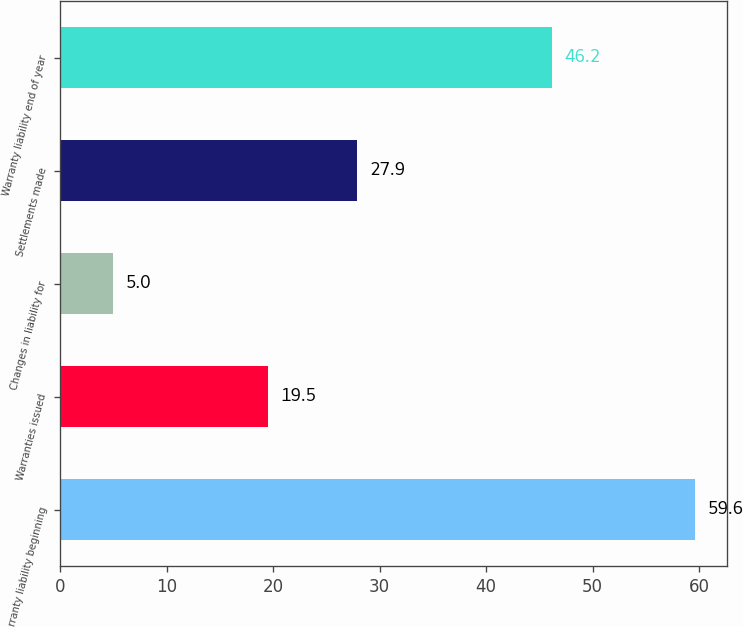Convert chart to OTSL. <chart><loc_0><loc_0><loc_500><loc_500><bar_chart><fcel>Warranty liability beginning<fcel>Warranties issued<fcel>Changes in liability for<fcel>Settlements made<fcel>Warranty liability end of year<nl><fcel>59.6<fcel>19.5<fcel>5<fcel>27.9<fcel>46.2<nl></chart> 